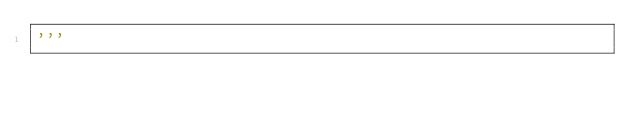Convert code to text. <code><loc_0><loc_0><loc_500><loc_500><_Python_>'''
</code> 